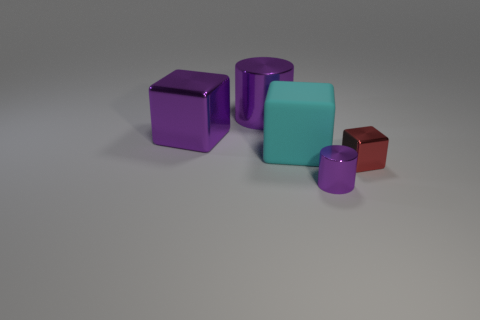There is a shiny cube that is on the left side of the tiny cube; is its color the same as the cylinder behind the small metallic cube?
Give a very brief answer. Yes. There is a metallic cylinder that is the same size as the red cube; what color is it?
Make the answer very short. Purple. Is the number of small purple things behind the big matte block the same as the number of cubes that are behind the big cylinder?
Offer a terse response. Yes. There is a purple cylinder to the left of the small purple thing that is in front of the purple metallic block; what is it made of?
Provide a succinct answer. Metal. What number of objects are big brown shiny cubes or purple cylinders?
Your answer should be compact. 2. The shiny block that is the same color as the large cylinder is what size?
Your answer should be very brief. Large. Is the number of brown metallic blocks less than the number of large purple metallic things?
Provide a succinct answer. Yes. There is a red object that is the same material as the small purple thing; what is its size?
Your answer should be very brief. Small. The matte cube is what size?
Ensure brevity in your answer.  Large. What shape is the tiny purple shiny thing?
Offer a very short reply. Cylinder. 